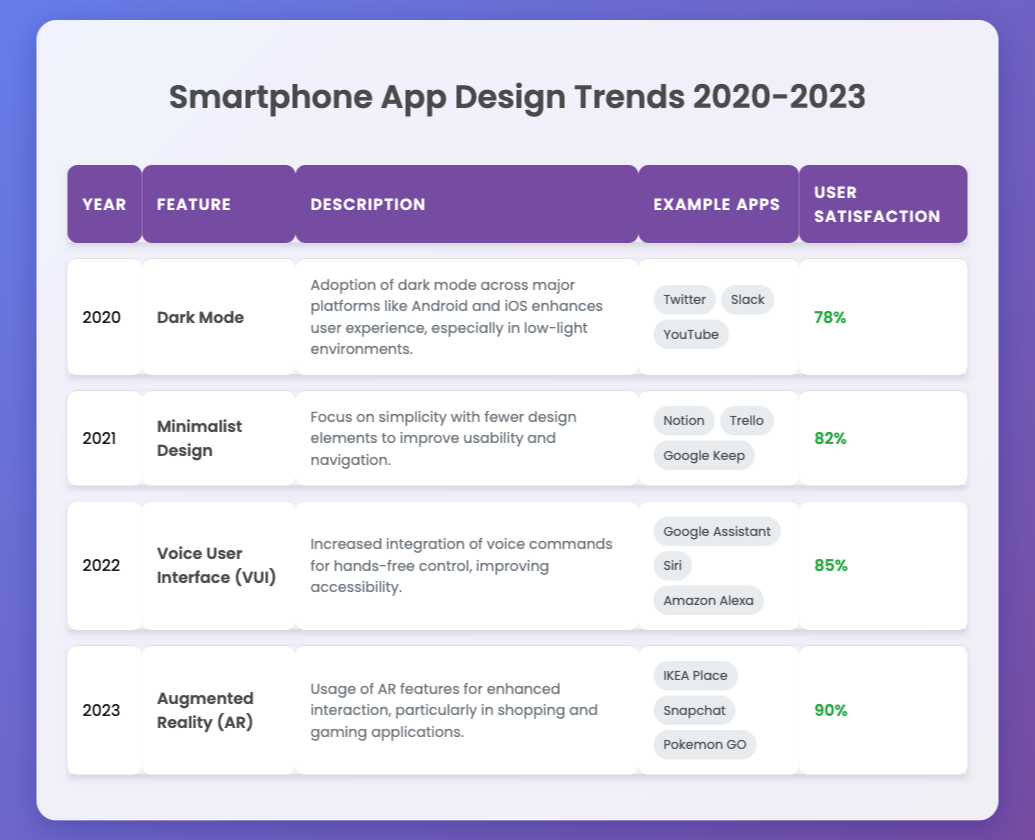What design feature had the highest user satisfaction in 2023? The feature in 2023 is Augmented Reality (AR) with a user satisfaction of 90%.
Answer: Augmented Reality (AR) Which year saw the introduction of Voice User Interface (VUI)? Voice User Interface (VUI) was introduced in the year 2022.
Answer: 2022 What was the average user satisfaction for features from 2020 to 2022? We sum the user satisfaction rates for those years: 78% + 82% + 85% = 245%. There are 3 data points, so the average is 245% / 3 = 81.67%.
Answer: 81.67% Did the user satisfaction improve from Dark Mode in 2020 to Augmented Reality in 2023? Yes, user satisfaction increased from 78% in 2020 to 90% in 2023.
Answer: Yes Which feature had the lowest user satisfaction, and what was the percentage? Dark Mode had the lowest user satisfaction of 78%.
Answer: Dark Mode, 78% 